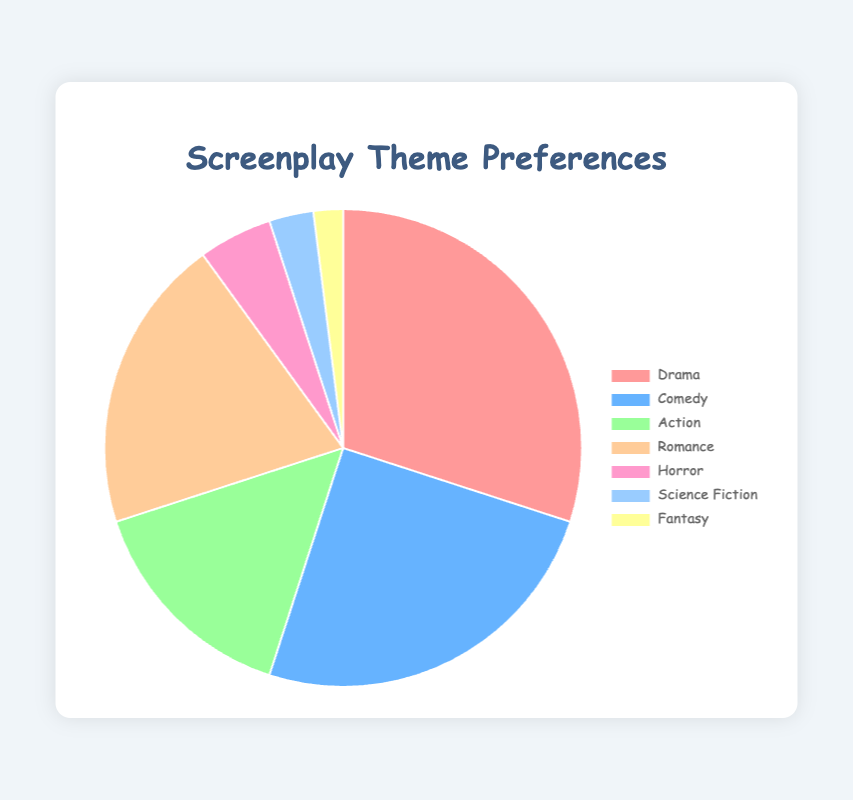Which genre is the most popular? The chart shows that Drama has the largest slice of the pie, with 30% of the preferences.
Answer: Drama Which genre is the least popular? The genre with the smallest slice is Fantasy with 2% of the preferences.
Answer: Fantasy How much more popular is Drama compared to Action? Drama has 30% while Action has 15%. So, Drama is 30% - 15% = 15% more popular than Action.
Answer: 15% What is the total percentage for Drama and Comedy together? Adding Drama with 30% and Comedy with 25%, the total is 30% + 25% = 55%.
Answer: 55% Which color represents the Horror genre? Horror is represented by a distinct color, which in this case is pinkish (#ff99cc) on the chart.
Answer: Pink Are there any genres that together account for less than 10%? Science Fiction (3%) and Fantasy (2%) together make 3% + 2% = 5%, which is less than 10%.
Answer: Yes Is Romance more popular than Comedy? Romance has 20% while Comedy has 25%, so Romance is less popular than Comedy.
Answer: No If the total preference for Action and Romance were combined, would they surpass Drama? Action has 15% and Romance has 20%. Combined, they are 15% + 20% = 35%, which surpasses Drama's 30%.
Answer: Yes How many genres have a preference percentage greater than or equal to 20%? Drama (30%), Comedy (25%), and Romance (20%) meet this criterion. This totals 3 genres.
Answer: 3 Which two genres together have a combined preference percentage of exactly 25%? The only two genres that add up to 25% are Horror (5%) and Science Fiction (3%), which totals 8%, so no two genres combine to exactly 25%.
Answer: None 